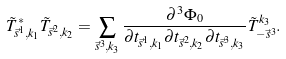<formula> <loc_0><loc_0><loc_500><loc_500>\tilde { T } _ { \vec { s } ^ { 1 } , k _ { 1 } } ^ { * } \tilde { T } _ { \vec { s } ^ { 2 } , k _ { 2 } } = \sum _ { \vec { s } ^ { 3 } , k _ { 3 } } \frac { \partial ^ { 3 } \Phi _ { 0 } } { \partial t _ { \vec { s } ^ { 1 } , k _ { 1 } } \partial t _ { \vec { s } ^ { 2 } , k _ { 2 } } \partial t _ { \vec { s } ^ { 3 } , k _ { 3 } } } \tilde { T } _ { - \vec { s } ^ { 3 } } ^ { k _ { 3 } } .</formula> 